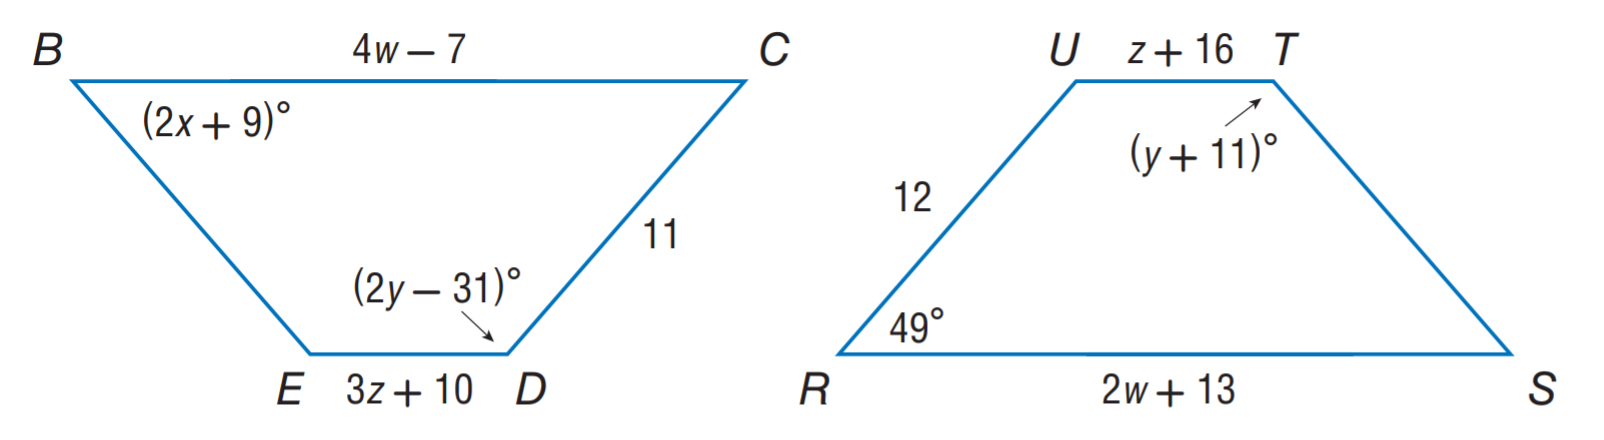Answer the mathemtical geometry problem and directly provide the correct option letter.
Question: Polygon B C D E \cong polygon R S T U. Find w.
Choices: A: 3 B: 10 C: 20 D: 42 B 